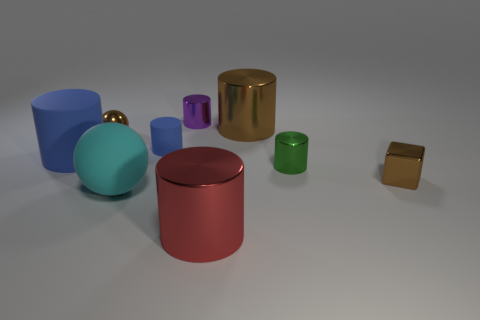There is a brown shiny object to the left of the blue rubber thing right of the large cyan object; how big is it?
Offer a terse response. Small. There is a red object that is the same size as the cyan thing; what material is it?
Offer a terse response. Metal. Are there any red metal things right of the brown cylinder?
Provide a short and direct response. No. Is the number of large cylinders in front of the small blue rubber object the same as the number of cubes?
Make the answer very short. No. There is a green metal object that is the same size as the purple object; what shape is it?
Ensure brevity in your answer.  Cylinder. What material is the large red cylinder?
Provide a succinct answer. Metal. There is a shiny object that is in front of the small purple metal object and behind the tiny brown ball; what is its color?
Give a very brief answer. Brown. Is the number of red metallic objects that are on the left side of the brown shiny ball the same as the number of small metal cylinders in front of the purple metallic cylinder?
Make the answer very short. No. There is a small ball that is the same material as the red cylinder; what color is it?
Ensure brevity in your answer.  Brown. There is a tiny shiny sphere; is its color the same as the metal cylinder that is in front of the large sphere?
Offer a terse response. No. 